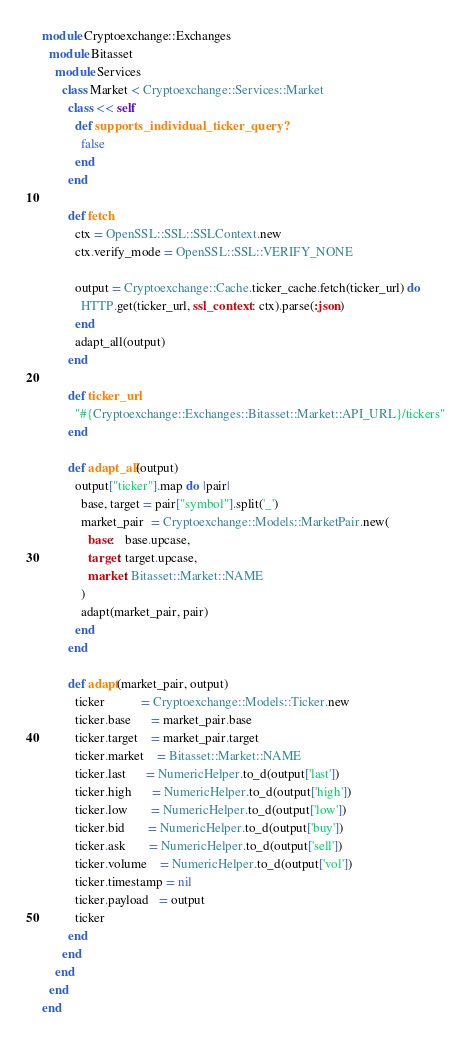<code> <loc_0><loc_0><loc_500><loc_500><_Ruby_>module Cryptoexchange::Exchanges
  module Bitasset
    module Services
      class Market < Cryptoexchange::Services::Market
        class << self
          def supports_individual_ticker_query?
            false
          end
        end

        def fetch
          ctx = OpenSSL::SSL::SSLContext.new
          ctx.verify_mode = OpenSSL::SSL::VERIFY_NONE

          output = Cryptoexchange::Cache.ticker_cache.fetch(ticker_url) do
            HTTP.get(ticker_url, ssl_context: ctx).parse(:json)
          end
          adapt_all(output)
        end

        def ticker_url
          "#{Cryptoexchange::Exchanges::Bitasset::Market::API_URL}/tickers"
        end

        def adapt_all(output)
          output["ticker"].map do |pair|
            base, target = pair["symbol"].split('_')
            market_pair  = Cryptoexchange::Models::MarketPair.new(
              base:   base.upcase,
              target: target.upcase,
              market: Bitasset::Market::NAME
            )
            adapt(market_pair, pair)
          end
        end

        def adapt(market_pair, output)
          ticker           = Cryptoexchange::Models::Ticker.new
          ticker.base      = market_pair.base
          ticker.target    = market_pair.target
          ticker.market    = Bitasset::Market::NAME
          ticker.last      = NumericHelper.to_d(output['last'])
          ticker.high      = NumericHelper.to_d(output['high'])
          ticker.low       = NumericHelper.to_d(output['low'])
          ticker.bid       = NumericHelper.to_d(output['buy'])
          ticker.ask       = NumericHelper.to_d(output['sell'])
          ticker.volume    = NumericHelper.to_d(output['vol'])
          ticker.timestamp = nil
          ticker.payload   = output
          ticker
        end
      end
    end
  end
end
</code> 